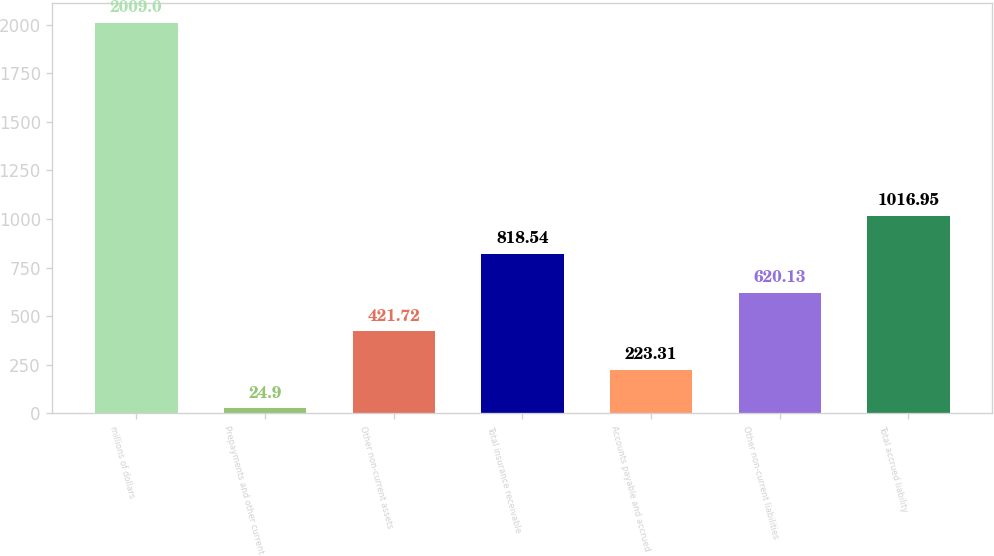<chart> <loc_0><loc_0><loc_500><loc_500><bar_chart><fcel>millions of dollars<fcel>Prepayments and other current<fcel>Other non-current assets<fcel>Total insurance receivable<fcel>Accounts payable and accrued<fcel>Other non-current liabilities<fcel>Total accrued liability<nl><fcel>2009<fcel>24.9<fcel>421.72<fcel>818.54<fcel>223.31<fcel>620.13<fcel>1016.95<nl></chart> 